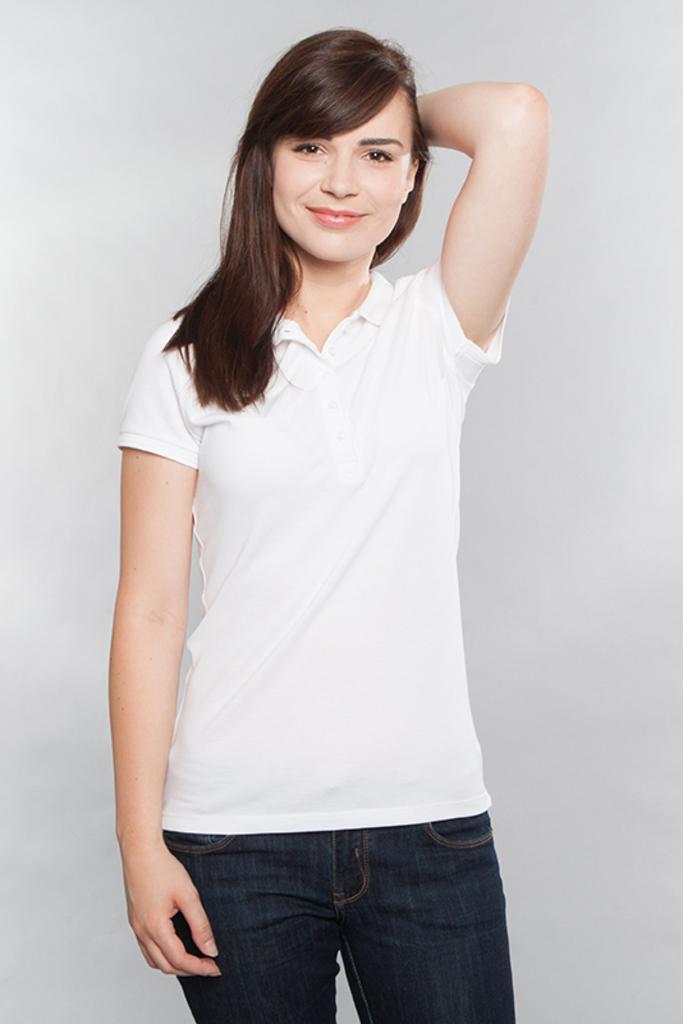Describe this image in one or two sentences. In this picture I can see a woman standing and I can see a plain background. 